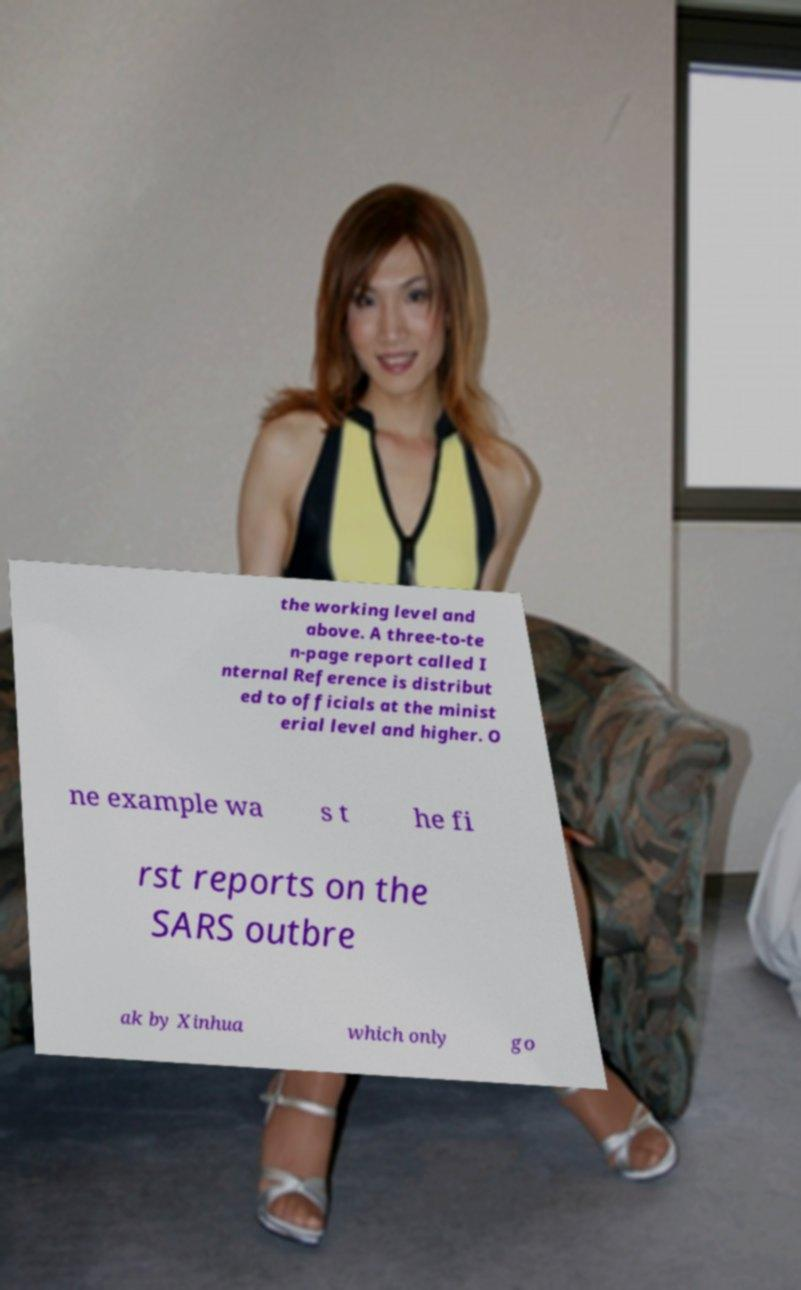Please read and relay the text visible in this image. What does it say? the working level and above. A three-to-te n-page report called I nternal Reference is distribut ed to officials at the minist erial level and higher. O ne example wa s t he fi rst reports on the SARS outbre ak by Xinhua which only go 